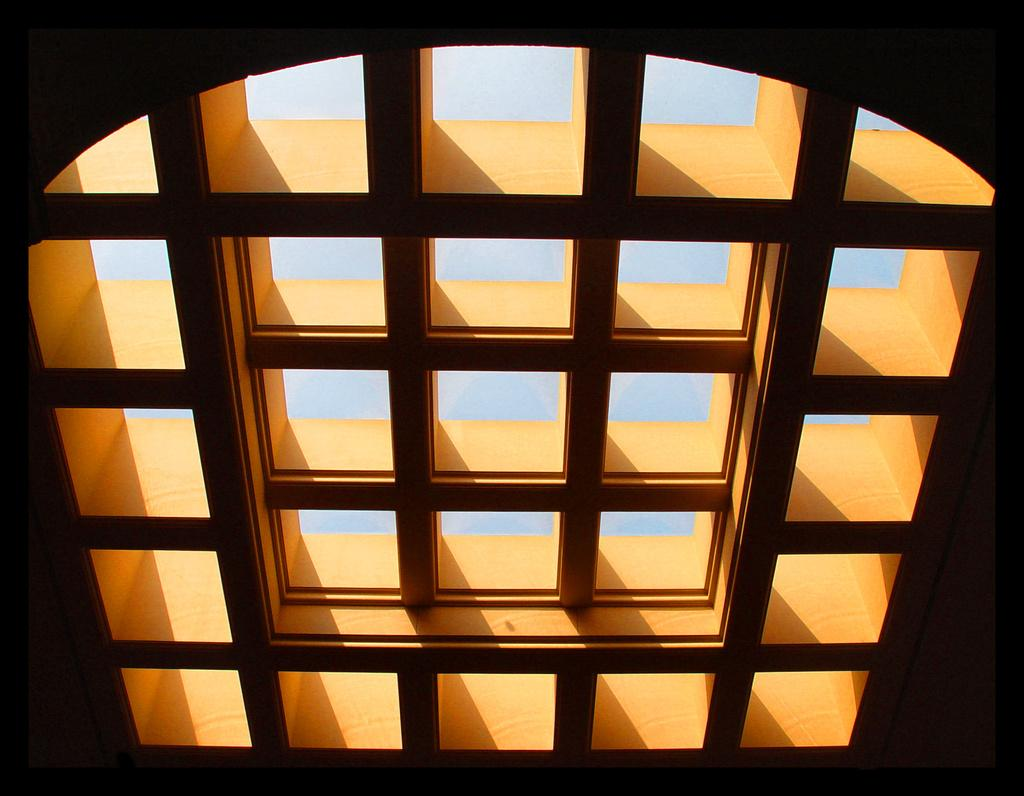What part of a building can be seen in the image? The roof is visible in the image. What type of power source is visible on the roof in the image? There is no power source visible on the roof in the image. What can be seen on the roof that resembles a tongue? There is no tongue-like object present on the roof in the image. How many dimes can be seen scattered on the roof in the image? There are no dimes present on the roof in the image. 